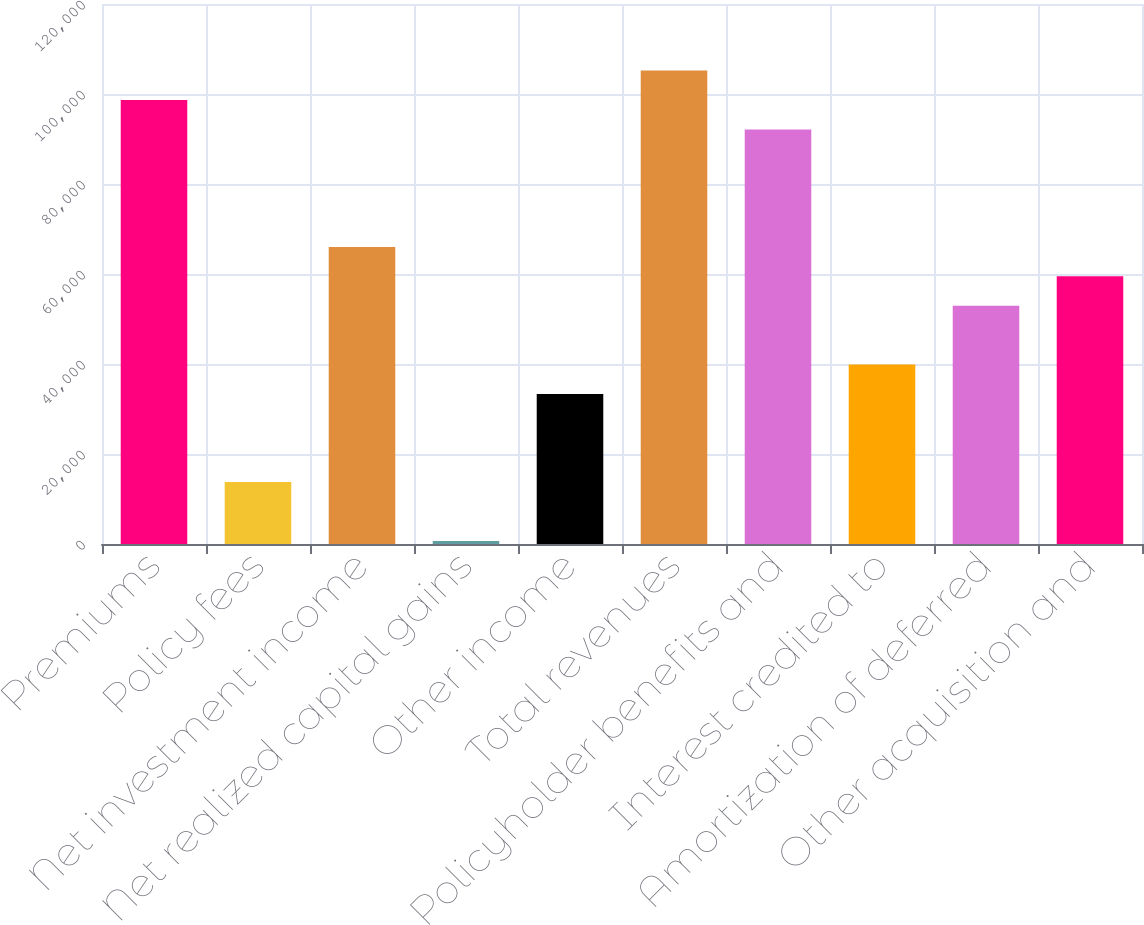Convert chart. <chart><loc_0><loc_0><loc_500><loc_500><bar_chart><fcel>Premiums<fcel>Policy fees<fcel>Net investment income<fcel>Net realized capital gains<fcel>Other income<fcel>Total revenues<fcel>Policyholder benefits and<fcel>Interest credited to<fcel>Amortization of deferred<fcel>Other acquisition and<nl><fcel>98663.5<fcel>13754<fcel>66006<fcel>691<fcel>33348.5<fcel>105195<fcel>92132<fcel>39880<fcel>52943<fcel>59474.5<nl></chart> 